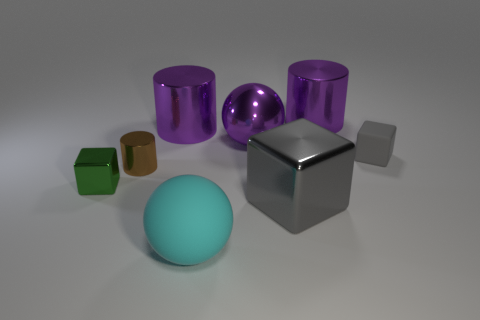Add 1 large gray blocks. How many objects exist? 9 Subtract all cylinders. How many objects are left? 5 Subtract 0 yellow cylinders. How many objects are left? 8 Subtract all large purple metallic balls. Subtract all large metallic spheres. How many objects are left? 6 Add 5 metallic spheres. How many metallic spheres are left? 6 Add 2 green rubber blocks. How many green rubber blocks exist? 2 